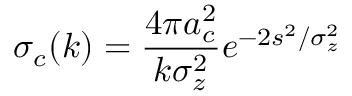Convert formula to latex. <formula><loc_0><loc_0><loc_500><loc_500>\sigma _ { c } ( k ) = \frac { 4 \pi a _ { c } ^ { 2 } } { k \sigma _ { z } ^ { 2 } } e ^ { - 2 s ^ { 2 } / \sigma _ { z } ^ { 2 } }</formula> 